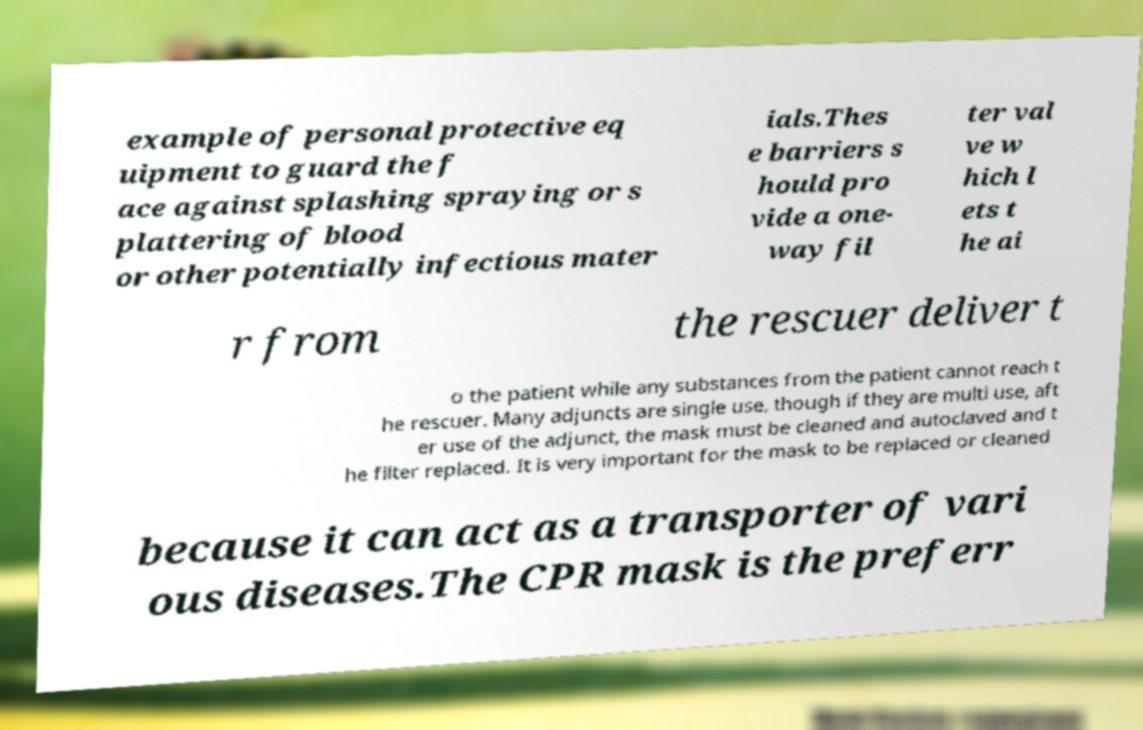Please read and relay the text visible in this image. What does it say? example of personal protective eq uipment to guard the f ace against splashing spraying or s plattering of blood or other potentially infectious mater ials.Thes e barriers s hould pro vide a one- way fil ter val ve w hich l ets t he ai r from the rescuer deliver t o the patient while any substances from the patient cannot reach t he rescuer. Many adjuncts are single use, though if they are multi use, aft er use of the adjunct, the mask must be cleaned and autoclaved and t he filter replaced. It is very important for the mask to be replaced or cleaned because it can act as a transporter of vari ous diseases.The CPR mask is the preferr 